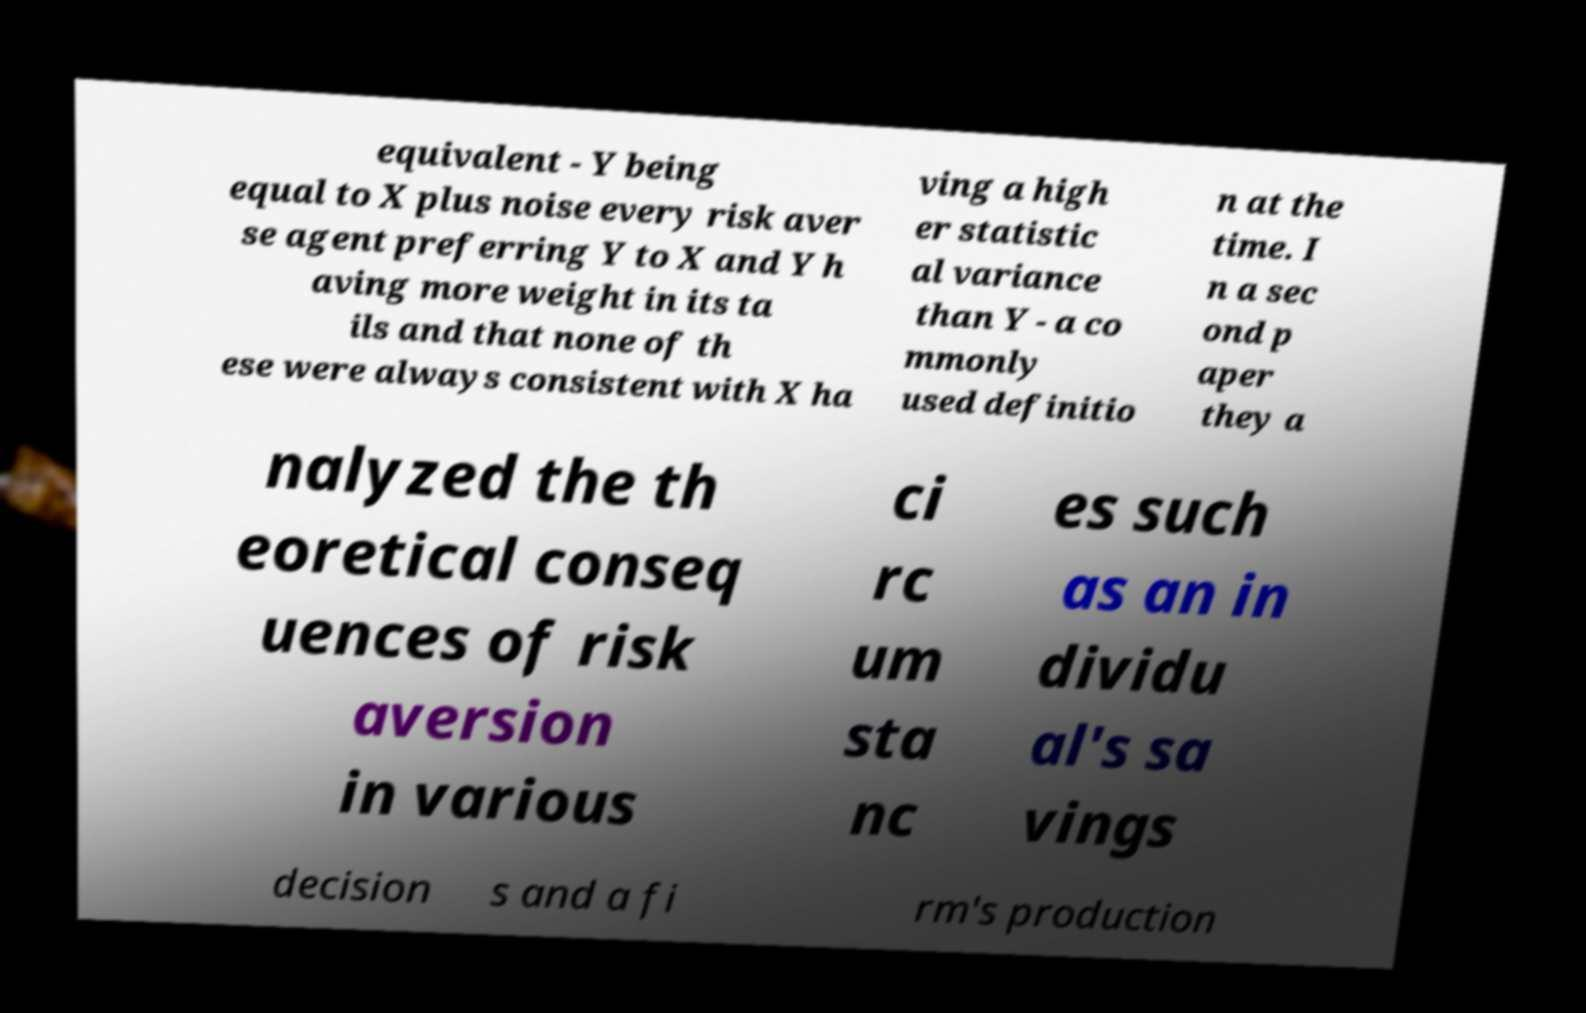Please read and relay the text visible in this image. What does it say? equivalent - Y being equal to X plus noise every risk aver se agent preferring Y to X and Y h aving more weight in its ta ils and that none of th ese were always consistent with X ha ving a high er statistic al variance than Y - a co mmonly used definitio n at the time. I n a sec ond p aper they a nalyzed the th eoretical conseq uences of risk aversion in various ci rc um sta nc es such as an in dividu al's sa vings decision s and a fi rm's production 